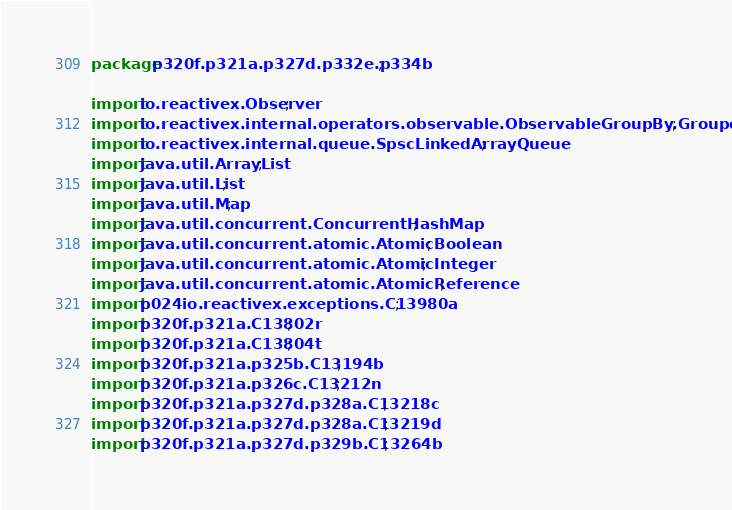Convert code to text. <code><loc_0><loc_0><loc_500><loc_500><_Java_>package p320f.p321a.p327d.p332e.p334b;

import io.reactivex.Observer;
import io.reactivex.internal.operators.observable.ObservableGroupBy.GroupedUnicast;
import io.reactivex.internal.queue.SpscLinkedArrayQueue;
import java.util.ArrayList;
import java.util.List;
import java.util.Map;
import java.util.concurrent.ConcurrentHashMap;
import java.util.concurrent.atomic.AtomicBoolean;
import java.util.concurrent.atomic.AtomicInteger;
import java.util.concurrent.atomic.AtomicReference;
import p024io.reactivex.exceptions.C13980a;
import p320f.p321a.C13802r;
import p320f.p321a.C13804t;
import p320f.p321a.p325b.C13194b;
import p320f.p321a.p326c.C13212n;
import p320f.p321a.p327d.p328a.C13218c;
import p320f.p321a.p327d.p328a.C13219d;
import p320f.p321a.p327d.p329b.C13264b;</code> 